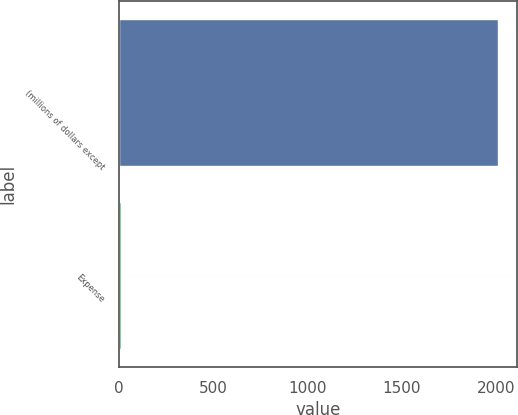Convert chart. <chart><loc_0><loc_0><loc_500><loc_500><bar_chart><fcel>(millions of dollars except<fcel>Expense<nl><fcel>2014<fcel>11.4<nl></chart> 